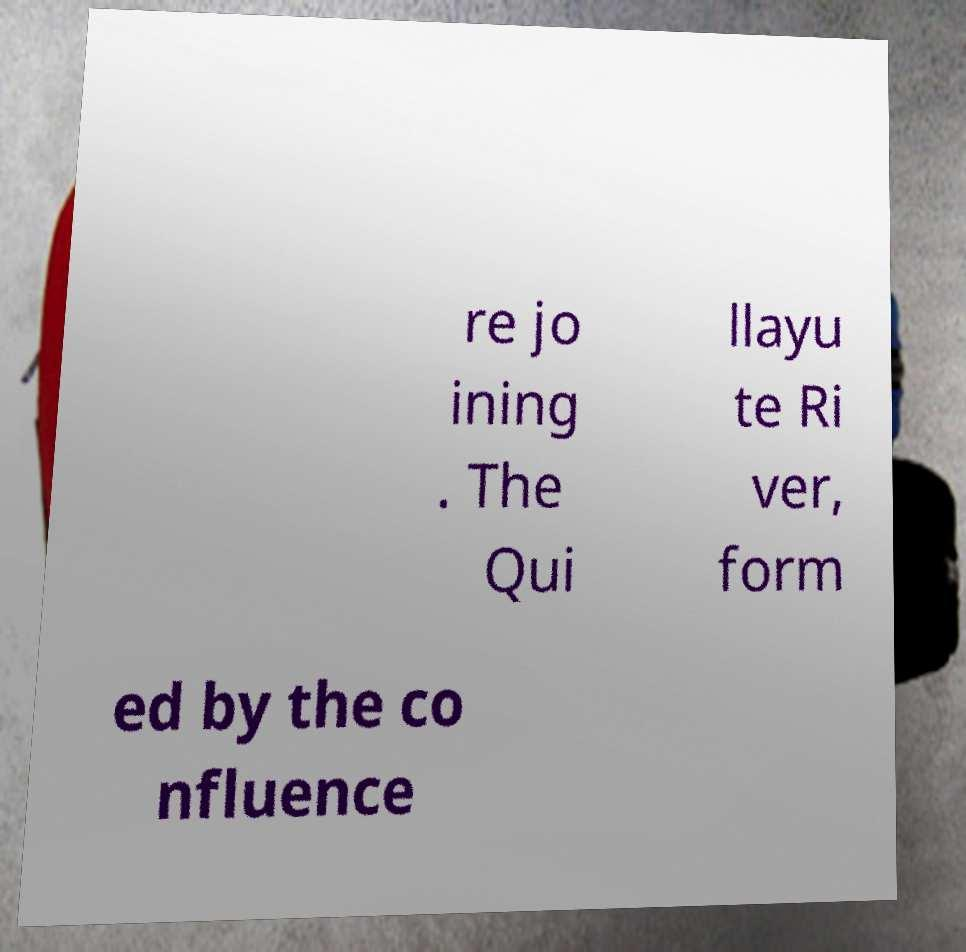Can you accurately transcribe the text from the provided image for me? re jo ining . The Qui llayu te Ri ver, form ed by the co nfluence 